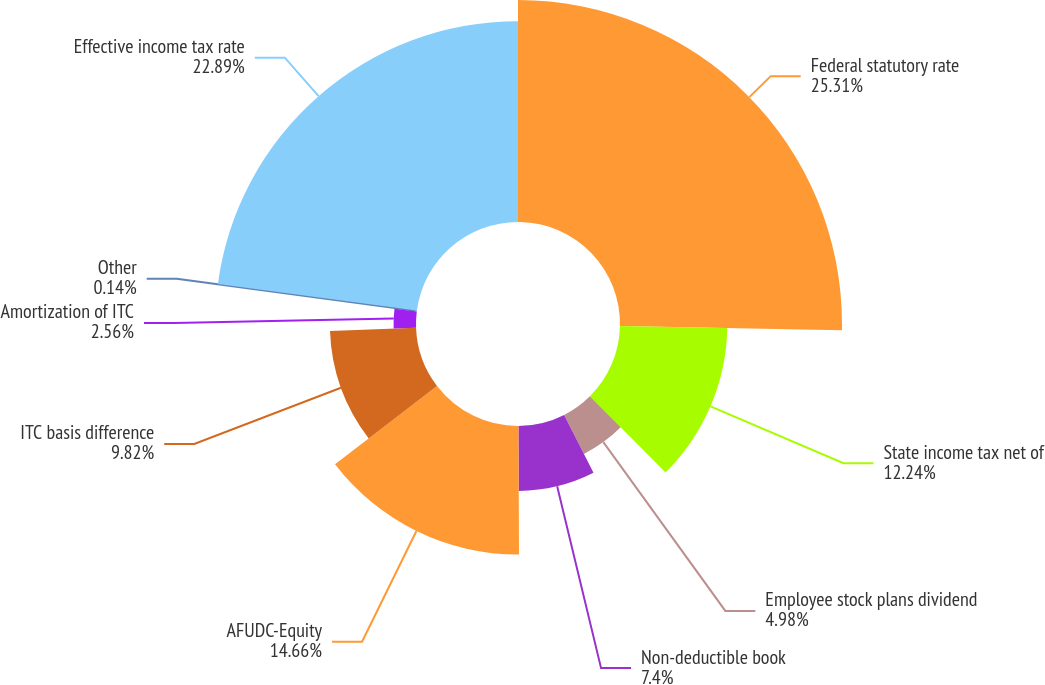<chart> <loc_0><loc_0><loc_500><loc_500><pie_chart><fcel>Federal statutory rate<fcel>State income tax net of<fcel>Employee stock plans dividend<fcel>Non-deductible book<fcel>AFUDC-Equity<fcel>ITC basis difference<fcel>Amortization of ITC<fcel>Other<fcel>Effective income tax rate<nl><fcel>25.31%<fcel>12.24%<fcel>4.98%<fcel>7.4%<fcel>14.66%<fcel>9.82%<fcel>2.56%<fcel>0.14%<fcel>22.89%<nl></chart> 